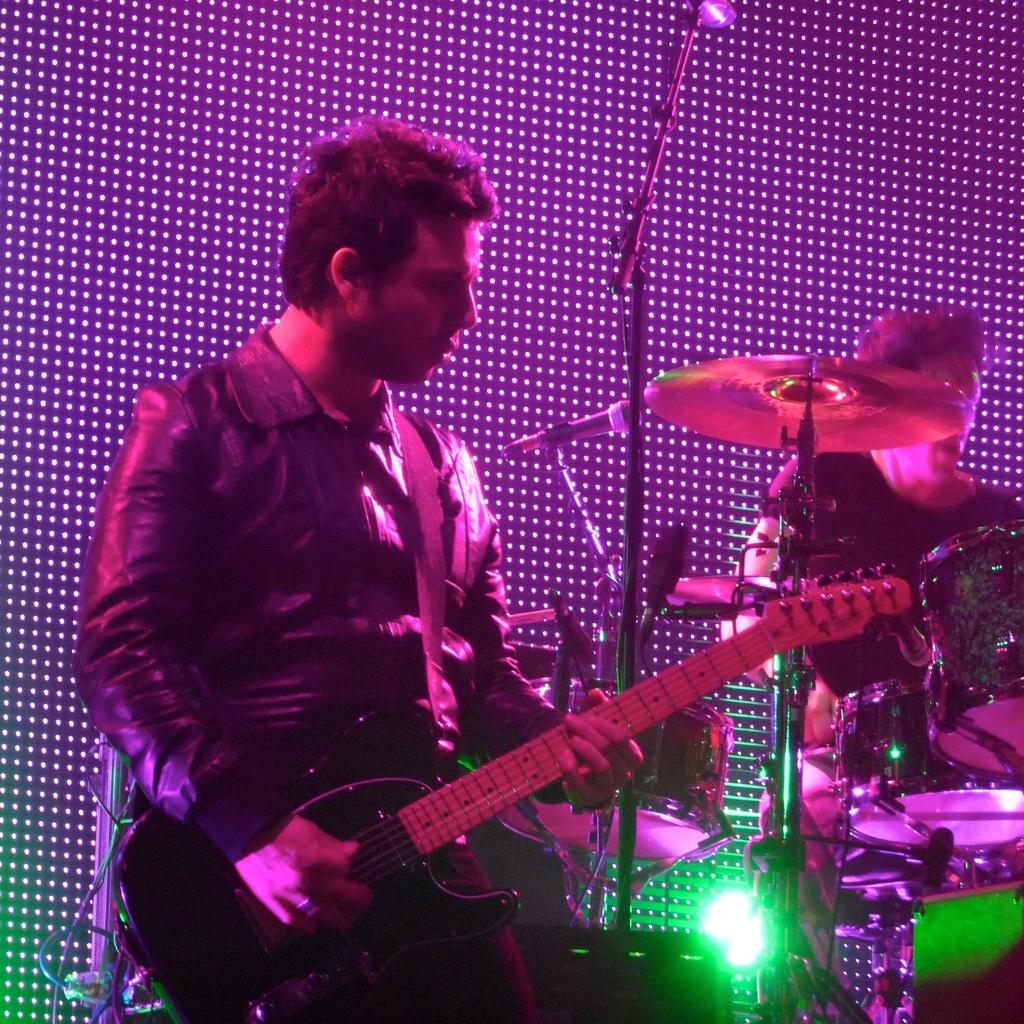Please provide a concise description of this image. In this image we can see a person playing with a musical instrument. In the background of the image there is a person, musical instruments, lights and other objects. 